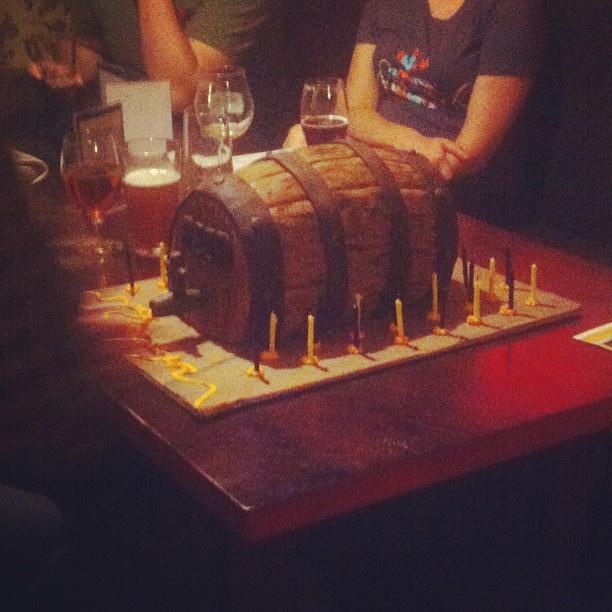Could this person be turning 21?
Be succinct. Yes. What is the cake design?
Concise answer only. Barrel. What kind of food is this?
Write a very short answer. Cake. 